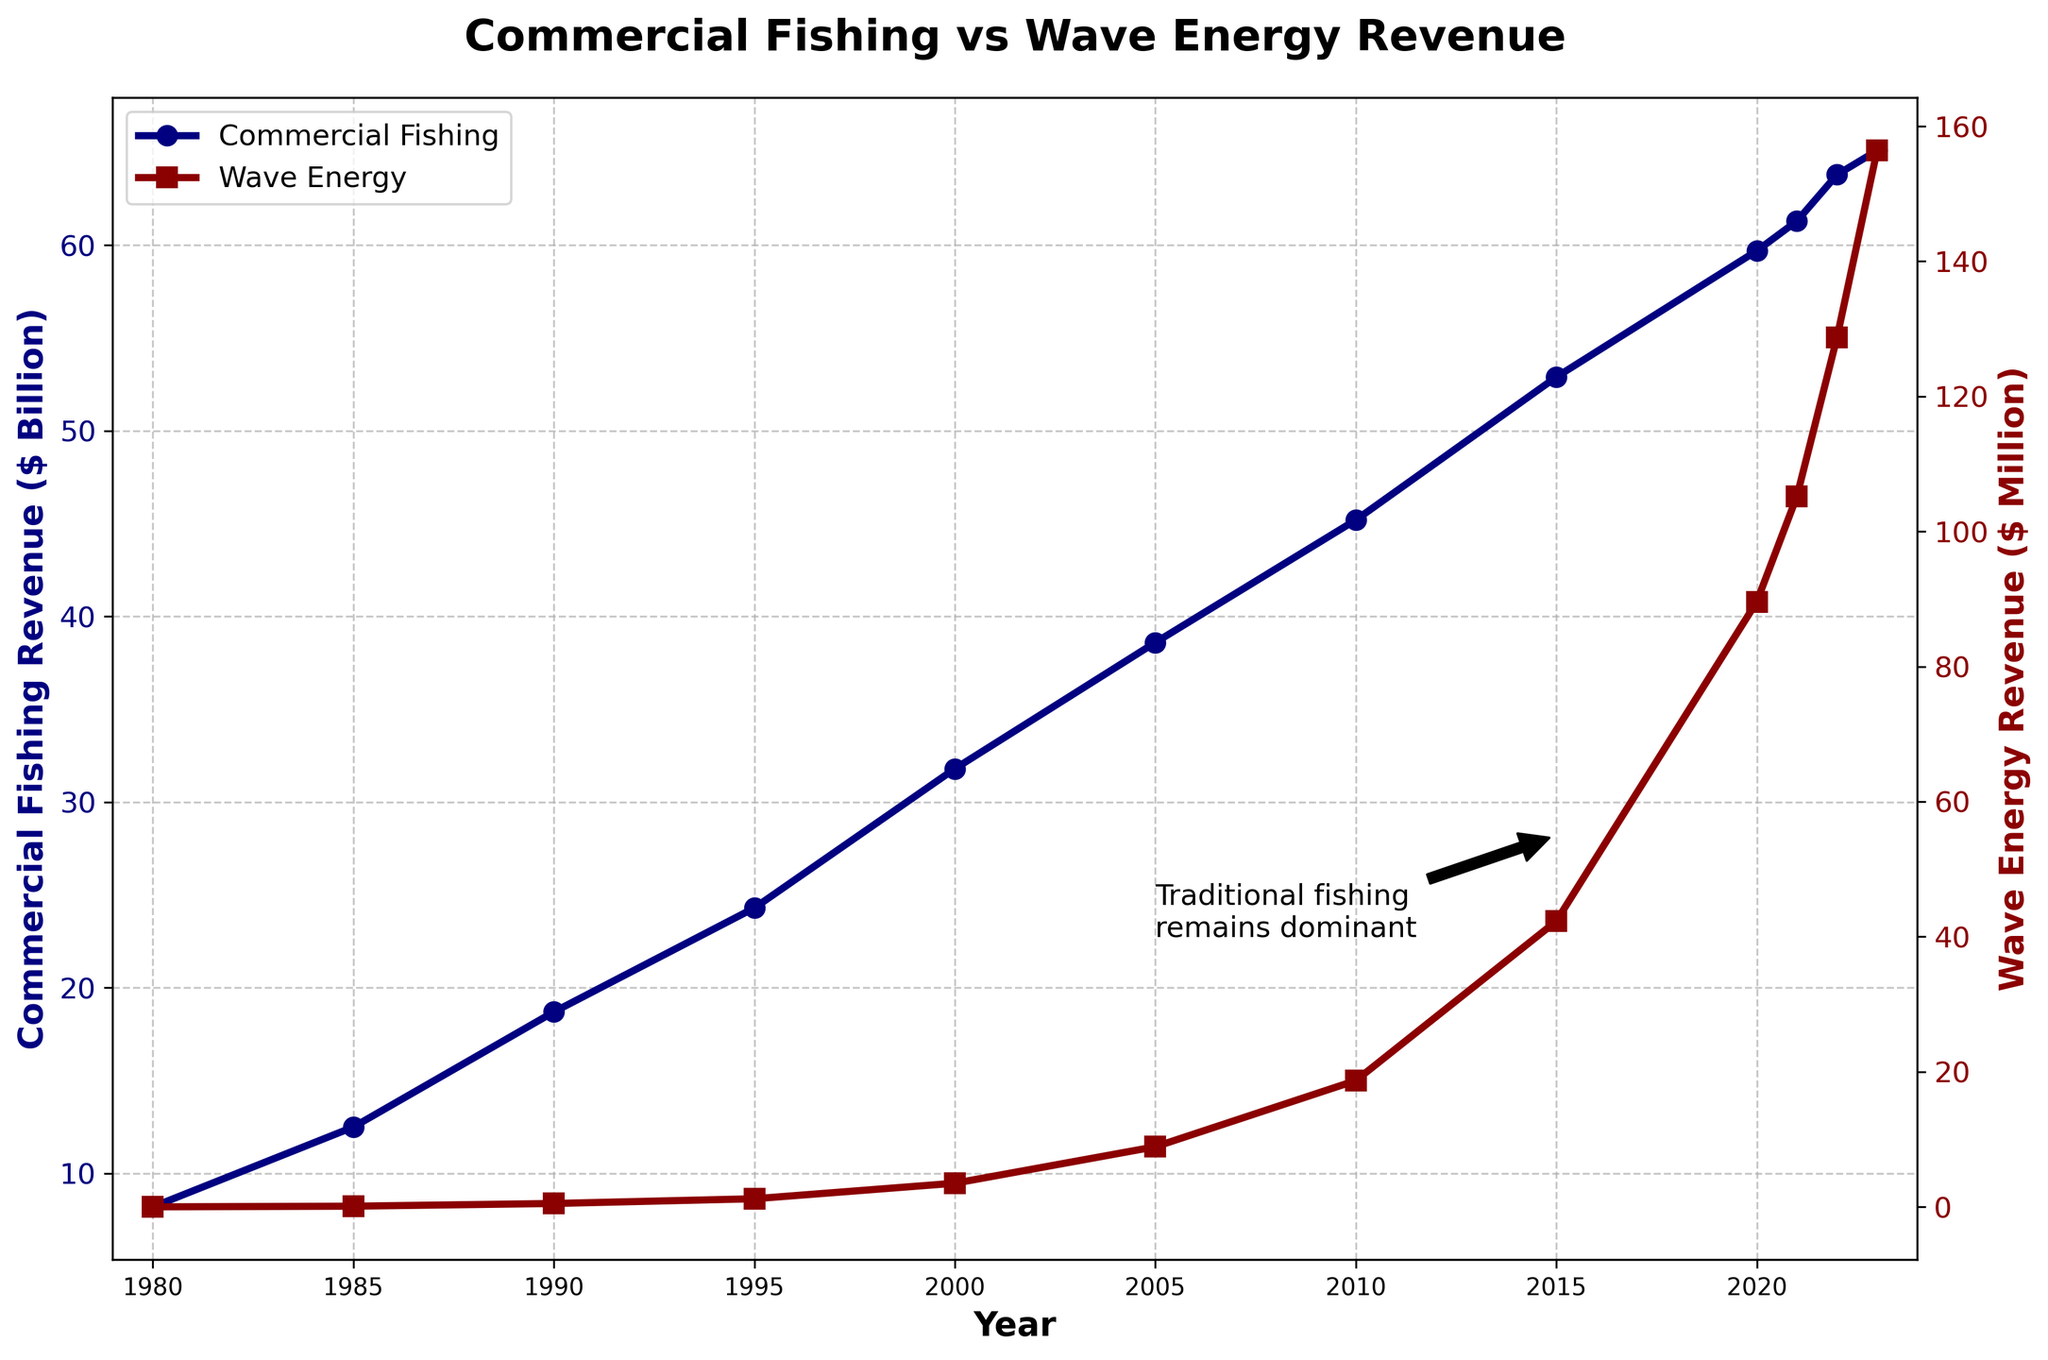How has the commercial fishing revenue changed from 1980 to 2023? By looking at the line chart for commercial fishing, the revenue has steadily increased from $8.2 billion in 1980 to $65.1 billion in 2023.
Answer: It has increased In which year did the wave energy revenue first surpass $100 million? Referring to the line chart for wave energy, the revenue first surpasses $100 million in the year 2021.
Answer: 2021 How does the revenue trend of wave energy compare to commercial fishing over the years? Commercial fishing revenue shows a steady, more gradual increase, while wave energy shows a much sharper and exponential increase, especially after 2000.
Answer: Wave energy shows exponential growth What was the combined revenue of both sectors in 2000? The commercial fishing revenue was $31.8 billion, and wave energy was $3.5 million. Converting wave energy to billion, 3.5/1000 = 0.0035. So, combined revenue = 31.8 + 0.0035 = 31.8035 billion dollars.
Answer: 31.8035 billion dollars Which sector had the steeper average annual increase in revenue between 1980 and 2023? Calculate the difference in revenue for each sector and divide by the time span (43 years). For fishing: (65.1-8.2)/43 ≈ 1.33 billion/year; for wave energy: (156.4-0)/43 ≈ 3.64 million/year, converting to billion: 0.00364. The wave energy sector had a steeper average increase when converted to the same unit (billion dollars).
Answer: Wave energy What were the revenue values for commercial fishing and wave energy in the year 1990? Referring to the line chart, in 1990, commercial fishing revenue was $18.7 billion and wave energy was $0.5 million.
Answer: $18.7 billion (commercial fishing), $0.5 million (wave energy) Is there any year where the wave energy revenue growth seems to accelerate notably? The line chart shows that wave energy revenue growth notably accelerated around 2000, where the slope becomes significantly steeper.
Answer: Around 2000 Between 2010 and 2020, which sector experienced a larger absolute growth in revenue, and by how much? For commercial fishing: 59.7 - 45.2 = 14.5 billion; for wave energy: 89.6 - 18.7 = 70.9 million, converting to billion: 0.0709 billion. The larger absolute growth is in commercial fishing: 14.5 - 0.0709 = 14.4291 billion.
Answer: Commercial fishing by 14.4291 billion What is the visual difference in the marker styles used to represent the two sectors' data points? The commercial fishing data points are marked with circles, while wave energy data points are marked with squares.
Answer: Circles for commercial fishing, squares for wave energy 